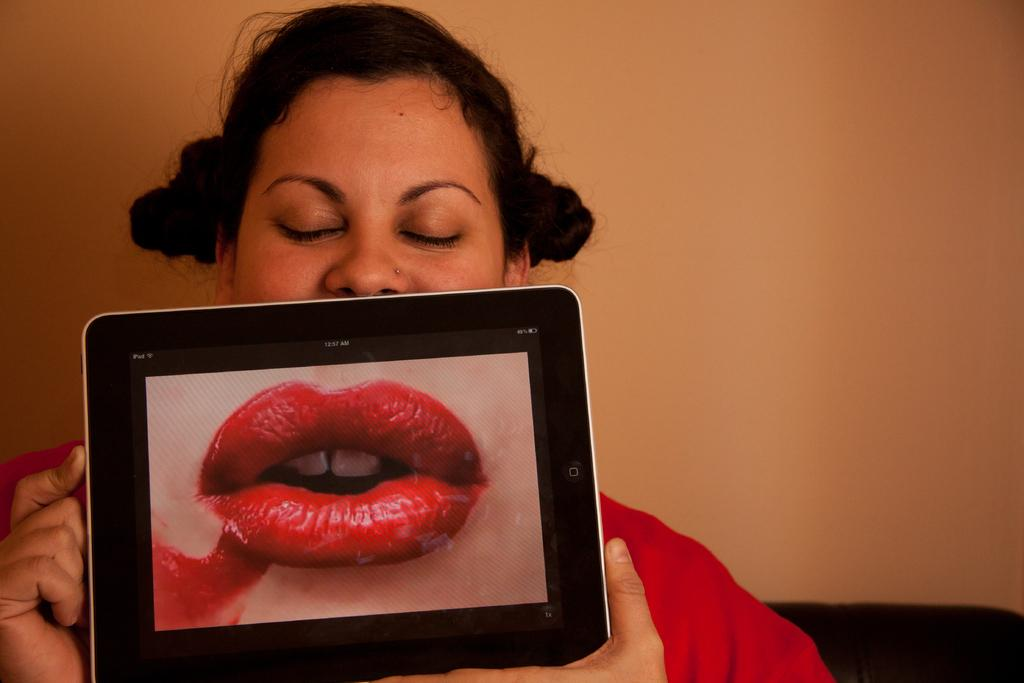Who is the main subject in the image? There is a girl in the image. What is the girl holding in the image? The girl is holding a tablet. What can be seen on the tablet's display? The tablet displays an image of lips. What can be seen in the background of the image? There is a wall in the background of the image. What is the flight number of the plane that the girl is waiting for at the airport in the image? There is no airport or plane present in the image; it features a girl holding a tablet with an image of lips displayed on it. 